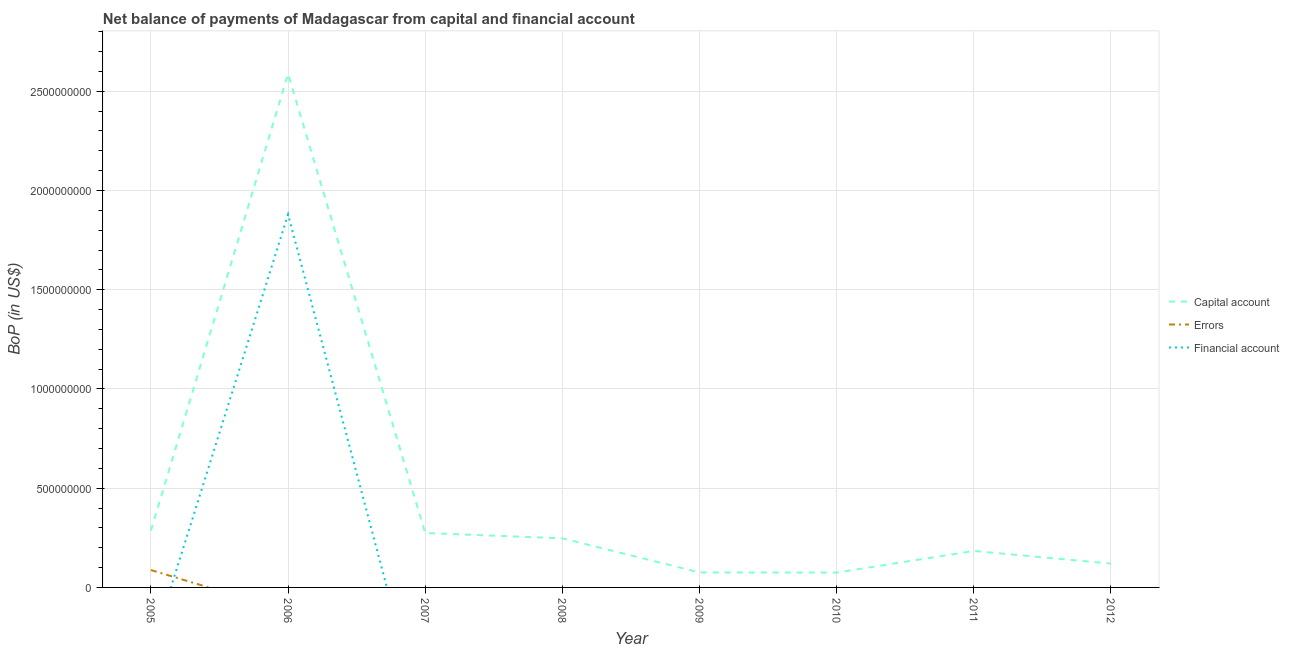How many different coloured lines are there?
Offer a very short reply. 3. Does the line corresponding to amount of errors intersect with the line corresponding to amount of financial account?
Your response must be concise. Yes. Across all years, what is the maximum amount of errors?
Make the answer very short. 8.76e+07. Across all years, what is the minimum amount of net capital account?
Offer a very short reply. 7.49e+07. In which year was the amount of financial account maximum?
Offer a terse response. 2006. What is the total amount of errors in the graph?
Your answer should be compact. 8.76e+07. What is the difference between the amount of net capital account in 2007 and that in 2009?
Offer a very short reply. 1.99e+08. What is the difference between the amount of net capital account in 2005 and the amount of financial account in 2009?
Your answer should be compact. 2.86e+08. What is the average amount of financial account per year?
Your response must be concise. 2.35e+08. In how many years, is the amount of net capital account greater than 500000000 US$?
Keep it short and to the point. 1. What is the ratio of the amount of net capital account in 2005 to that in 2009?
Provide a succinct answer. 3.79. What is the difference between the highest and the second highest amount of net capital account?
Give a very brief answer. 2.30e+09. What is the difference between the highest and the lowest amount of net capital account?
Provide a succinct answer. 2.51e+09. In how many years, is the amount of errors greater than the average amount of errors taken over all years?
Ensure brevity in your answer.  1. Is it the case that in every year, the sum of the amount of net capital account and amount of errors is greater than the amount of financial account?
Keep it short and to the point. Yes. Does the amount of net capital account monotonically increase over the years?
Your answer should be compact. No. Is the amount of financial account strictly greater than the amount of net capital account over the years?
Give a very brief answer. No. Is the amount of financial account strictly less than the amount of errors over the years?
Provide a short and direct response. No. How many lines are there?
Your response must be concise. 3. How many years are there in the graph?
Provide a succinct answer. 8. What is the difference between two consecutive major ticks on the Y-axis?
Your response must be concise. 5.00e+08. Are the values on the major ticks of Y-axis written in scientific E-notation?
Provide a short and direct response. No. Does the graph contain any zero values?
Ensure brevity in your answer.  Yes. Does the graph contain grids?
Provide a short and direct response. Yes. Where does the legend appear in the graph?
Provide a short and direct response. Center right. What is the title of the graph?
Your answer should be very brief. Net balance of payments of Madagascar from capital and financial account. What is the label or title of the Y-axis?
Offer a very short reply. BoP (in US$). What is the BoP (in US$) of Capital account in 2005?
Give a very brief answer. 2.86e+08. What is the BoP (in US$) of Errors in 2005?
Keep it short and to the point. 8.76e+07. What is the BoP (in US$) in Financial account in 2005?
Give a very brief answer. 0. What is the BoP (in US$) in Capital account in 2006?
Keep it short and to the point. 2.59e+09. What is the BoP (in US$) of Errors in 2006?
Keep it short and to the point. 0. What is the BoP (in US$) in Financial account in 2006?
Ensure brevity in your answer.  1.88e+09. What is the BoP (in US$) of Capital account in 2007?
Provide a succinct answer. 2.74e+08. What is the BoP (in US$) in Capital account in 2008?
Keep it short and to the point. 2.47e+08. What is the BoP (in US$) of Capital account in 2009?
Ensure brevity in your answer.  7.55e+07. What is the BoP (in US$) of Financial account in 2009?
Your answer should be compact. 0. What is the BoP (in US$) of Capital account in 2010?
Your answer should be very brief. 7.49e+07. What is the BoP (in US$) in Errors in 2010?
Your answer should be very brief. 0. What is the BoP (in US$) of Financial account in 2010?
Your answer should be compact. 0. What is the BoP (in US$) of Capital account in 2011?
Make the answer very short. 1.84e+08. What is the BoP (in US$) in Errors in 2011?
Make the answer very short. 0. What is the BoP (in US$) of Financial account in 2011?
Keep it short and to the point. 0. What is the BoP (in US$) in Capital account in 2012?
Your answer should be compact. 1.20e+08. What is the BoP (in US$) in Errors in 2012?
Ensure brevity in your answer.  0. What is the BoP (in US$) of Financial account in 2012?
Offer a terse response. 0. Across all years, what is the maximum BoP (in US$) in Capital account?
Your response must be concise. 2.59e+09. Across all years, what is the maximum BoP (in US$) of Errors?
Your answer should be compact. 8.76e+07. Across all years, what is the maximum BoP (in US$) in Financial account?
Your answer should be very brief. 1.88e+09. Across all years, what is the minimum BoP (in US$) of Capital account?
Provide a short and direct response. 7.49e+07. Across all years, what is the minimum BoP (in US$) of Errors?
Your response must be concise. 0. Across all years, what is the minimum BoP (in US$) in Financial account?
Provide a succinct answer. 0. What is the total BoP (in US$) of Capital account in the graph?
Ensure brevity in your answer.  3.85e+09. What is the total BoP (in US$) of Errors in the graph?
Your answer should be very brief. 8.76e+07. What is the total BoP (in US$) in Financial account in the graph?
Your response must be concise. 1.88e+09. What is the difference between the BoP (in US$) in Capital account in 2005 and that in 2006?
Your answer should be very brief. -2.30e+09. What is the difference between the BoP (in US$) of Capital account in 2005 and that in 2007?
Ensure brevity in your answer.  1.21e+07. What is the difference between the BoP (in US$) of Capital account in 2005 and that in 2008?
Your answer should be compact. 3.89e+07. What is the difference between the BoP (in US$) in Capital account in 2005 and that in 2009?
Your response must be concise. 2.11e+08. What is the difference between the BoP (in US$) of Capital account in 2005 and that in 2010?
Give a very brief answer. 2.11e+08. What is the difference between the BoP (in US$) in Capital account in 2005 and that in 2011?
Provide a short and direct response. 1.02e+08. What is the difference between the BoP (in US$) in Capital account in 2005 and that in 2012?
Ensure brevity in your answer.  1.66e+08. What is the difference between the BoP (in US$) of Capital account in 2006 and that in 2007?
Your answer should be compact. 2.31e+09. What is the difference between the BoP (in US$) of Capital account in 2006 and that in 2008?
Your response must be concise. 2.34e+09. What is the difference between the BoP (in US$) of Capital account in 2006 and that in 2009?
Offer a very short reply. 2.51e+09. What is the difference between the BoP (in US$) in Capital account in 2006 and that in 2010?
Offer a very short reply. 2.51e+09. What is the difference between the BoP (in US$) of Capital account in 2006 and that in 2011?
Your response must be concise. 2.40e+09. What is the difference between the BoP (in US$) in Capital account in 2006 and that in 2012?
Ensure brevity in your answer.  2.47e+09. What is the difference between the BoP (in US$) in Capital account in 2007 and that in 2008?
Ensure brevity in your answer.  2.68e+07. What is the difference between the BoP (in US$) in Capital account in 2007 and that in 2009?
Ensure brevity in your answer.  1.99e+08. What is the difference between the BoP (in US$) of Capital account in 2007 and that in 2010?
Offer a terse response. 1.99e+08. What is the difference between the BoP (in US$) of Capital account in 2007 and that in 2011?
Make the answer very short. 9.04e+07. What is the difference between the BoP (in US$) of Capital account in 2007 and that in 2012?
Offer a terse response. 1.54e+08. What is the difference between the BoP (in US$) of Capital account in 2008 and that in 2009?
Your response must be concise. 1.72e+08. What is the difference between the BoP (in US$) of Capital account in 2008 and that in 2010?
Your response must be concise. 1.72e+08. What is the difference between the BoP (in US$) of Capital account in 2008 and that in 2011?
Your answer should be compact. 6.35e+07. What is the difference between the BoP (in US$) of Capital account in 2008 and that in 2012?
Keep it short and to the point. 1.27e+08. What is the difference between the BoP (in US$) in Capital account in 2009 and that in 2010?
Keep it short and to the point. 5.31e+05. What is the difference between the BoP (in US$) of Capital account in 2009 and that in 2011?
Offer a very short reply. -1.08e+08. What is the difference between the BoP (in US$) of Capital account in 2009 and that in 2012?
Give a very brief answer. -4.45e+07. What is the difference between the BoP (in US$) in Capital account in 2010 and that in 2011?
Provide a succinct answer. -1.09e+08. What is the difference between the BoP (in US$) of Capital account in 2010 and that in 2012?
Offer a very short reply. -4.50e+07. What is the difference between the BoP (in US$) of Capital account in 2011 and that in 2012?
Your response must be concise. 6.40e+07. What is the difference between the BoP (in US$) of Capital account in 2005 and the BoP (in US$) of Financial account in 2006?
Your answer should be compact. -1.59e+09. What is the difference between the BoP (in US$) of Errors in 2005 and the BoP (in US$) of Financial account in 2006?
Offer a terse response. -1.79e+09. What is the average BoP (in US$) in Capital account per year?
Provide a short and direct response. 4.81e+08. What is the average BoP (in US$) of Errors per year?
Offer a very short reply. 1.09e+07. What is the average BoP (in US$) in Financial account per year?
Your answer should be very brief. 2.35e+08. In the year 2005, what is the difference between the BoP (in US$) of Capital account and BoP (in US$) of Errors?
Offer a terse response. 1.99e+08. In the year 2006, what is the difference between the BoP (in US$) in Capital account and BoP (in US$) in Financial account?
Offer a terse response. 7.08e+08. What is the ratio of the BoP (in US$) in Capital account in 2005 to that in 2006?
Provide a succinct answer. 0.11. What is the ratio of the BoP (in US$) in Capital account in 2005 to that in 2007?
Provide a succinct answer. 1.04. What is the ratio of the BoP (in US$) in Capital account in 2005 to that in 2008?
Your answer should be compact. 1.16. What is the ratio of the BoP (in US$) of Capital account in 2005 to that in 2009?
Your answer should be very brief. 3.79. What is the ratio of the BoP (in US$) in Capital account in 2005 to that in 2010?
Keep it short and to the point. 3.82. What is the ratio of the BoP (in US$) in Capital account in 2005 to that in 2011?
Give a very brief answer. 1.56. What is the ratio of the BoP (in US$) of Capital account in 2005 to that in 2012?
Your response must be concise. 2.39. What is the ratio of the BoP (in US$) of Capital account in 2006 to that in 2007?
Give a very brief answer. 9.44. What is the ratio of the BoP (in US$) of Capital account in 2006 to that in 2008?
Make the answer very short. 10.46. What is the ratio of the BoP (in US$) of Capital account in 2006 to that in 2009?
Provide a succinct answer. 34.29. What is the ratio of the BoP (in US$) of Capital account in 2006 to that in 2010?
Your response must be concise. 34.54. What is the ratio of the BoP (in US$) in Capital account in 2006 to that in 2011?
Your answer should be very brief. 14.07. What is the ratio of the BoP (in US$) of Capital account in 2006 to that in 2012?
Give a very brief answer. 21.58. What is the ratio of the BoP (in US$) of Capital account in 2007 to that in 2008?
Provide a short and direct response. 1.11. What is the ratio of the BoP (in US$) of Capital account in 2007 to that in 2009?
Provide a succinct answer. 3.63. What is the ratio of the BoP (in US$) of Capital account in 2007 to that in 2010?
Offer a terse response. 3.66. What is the ratio of the BoP (in US$) in Capital account in 2007 to that in 2011?
Your answer should be compact. 1.49. What is the ratio of the BoP (in US$) in Capital account in 2007 to that in 2012?
Offer a terse response. 2.29. What is the ratio of the BoP (in US$) of Capital account in 2008 to that in 2009?
Make the answer very short. 3.28. What is the ratio of the BoP (in US$) in Capital account in 2008 to that in 2010?
Offer a terse response. 3.3. What is the ratio of the BoP (in US$) in Capital account in 2008 to that in 2011?
Ensure brevity in your answer.  1.35. What is the ratio of the BoP (in US$) in Capital account in 2008 to that in 2012?
Give a very brief answer. 2.06. What is the ratio of the BoP (in US$) of Capital account in 2009 to that in 2010?
Ensure brevity in your answer.  1.01. What is the ratio of the BoP (in US$) of Capital account in 2009 to that in 2011?
Provide a short and direct response. 0.41. What is the ratio of the BoP (in US$) in Capital account in 2009 to that in 2012?
Give a very brief answer. 0.63. What is the ratio of the BoP (in US$) in Capital account in 2010 to that in 2011?
Ensure brevity in your answer.  0.41. What is the ratio of the BoP (in US$) of Capital account in 2010 to that in 2012?
Ensure brevity in your answer.  0.62. What is the ratio of the BoP (in US$) in Capital account in 2011 to that in 2012?
Your response must be concise. 1.53. What is the difference between the highest and the second highest BoP (in US$) in Capital account?
Make the answer very short. 2.30e+09. What is the difference between the highest and the lowest BoP (in US$) of Capital account?
Your response must be concise. 2.51e+09. What is the difference between the highest and the lowest BoP (in US$) in Errors?
Your response must be concise. 8.76e+07. What is the difference between the highest and the lowest BoP (in US$) of Financial account?
Offer a terse response. 1.88e+09. 